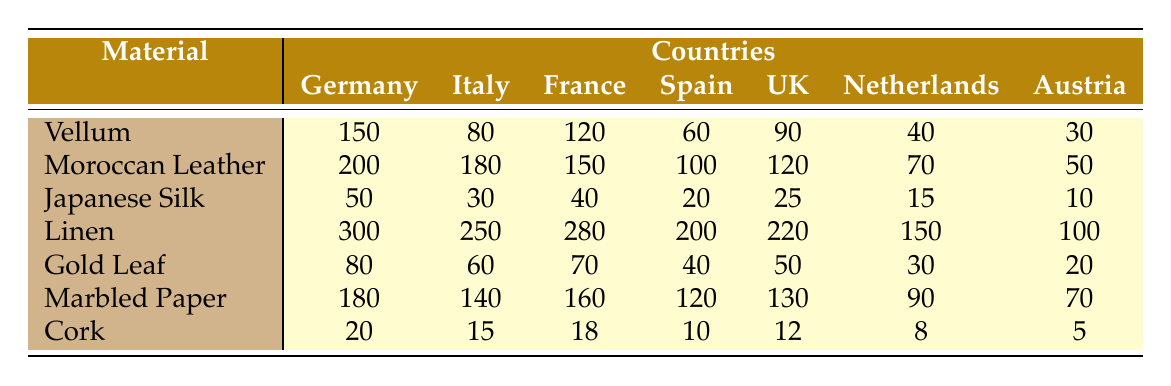What is the highest quantity of Vellum sourced from a country? The highest quantity of Vellum is 150, which comes from Germany.
Answer: 150 Which country sourced the least quantity of Japanese Silk? The least quantity of Japanese Silk is 10, sourced from Austria.
Answer: 10 What is the total quantity of Gold Leaf sourced across all countries? Adding up the quantities for Gold Leaf gives (80 + 60 + 70 + 40 + 50 + 30 + 20) = 350.
Answer: 350 Which material has the highest total quantity sourced from all countries combined? Calculating totals: Vellum (630), Moroccan Leather (870), Japanese Silk (165), Linen (1,300), Gold Leaf (350), Marbled Paper (860), Cork (80). Linen has the highest total quantity at 1,300.
Answer: Linen How many more units of Moroccan Leather did Italy source than France? The difference between Italy's and France's Moroccan Leather is 180 - 150 = 30.
Answer: 30 Was the total quantity of linen sourced from Spain more than that of Cork sourced from all countries? The total quantity of linen from Spain is 200 and the total for Cork is 10 (20 for Germany + 15 for Italy + 18 for France + 10 for Spain + 12 for UK + 8 for Netherlands + 5 for Austria = 88). Since 200 is greater than 88, the statement is true.
Answer: Yes Average the quantities of Marbled Paper across all countries. The average is calculated by summing the quantities (180 + 140 + 160 + 120 + 130 + 90 + 70) = 890, then dividing by 7 gives 890/7 = 127.14.
Answer: 127.14 Which country contributed the highest quantity of any single material? Scanning through the highest values, Linen from Germany is 300, which is the highest.
Answer: 300 What is the total quantity of materials sourced from Italy? By summing all the materials from Italy, we have (80 + 180 + 30 + 250 + 60 + 140 + 15) = 755.
Answer: 755 Which country sourced more than 200 units in total? The totals for countries are: Germany (630), Italy (870), France (165), Spain (1,100), UK (690), Netherlands (540), Austria (58). Spain and Italy sourced more than 200.
Answer: Spain and Italy 